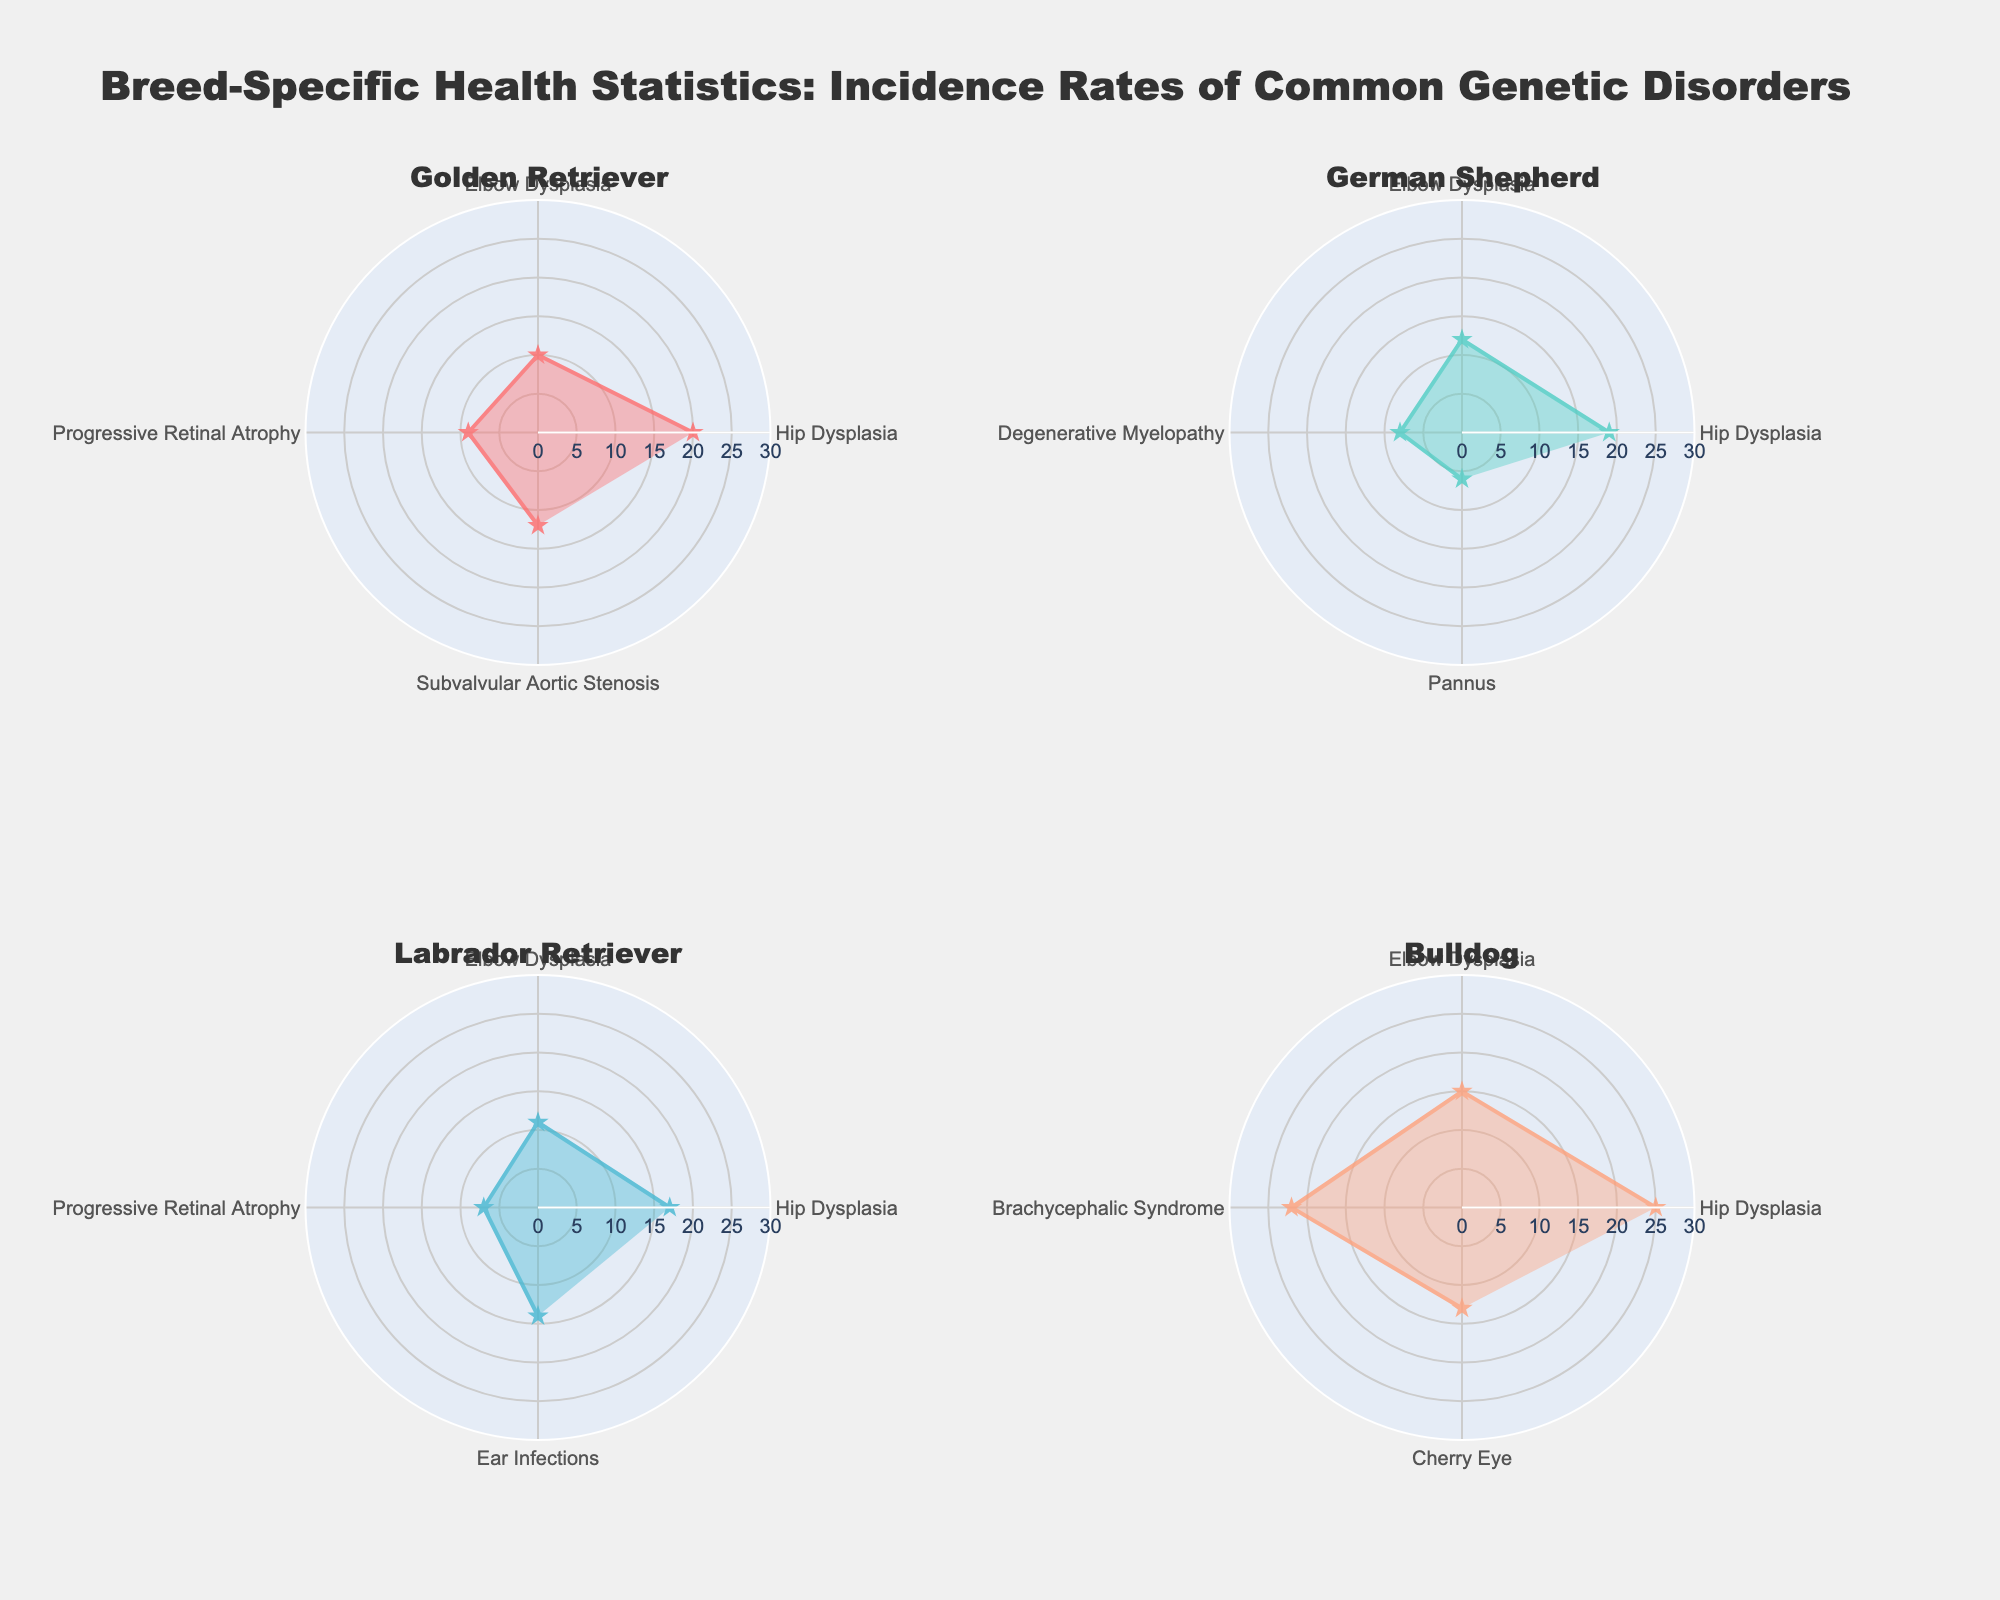What is the title of the figure? The title is usually placed at the top of the figure. In this case, the title is clearly visible in the large text.
Answer: Breed-Specific Health Statistics: Incidence Rates of Common Genetic Disorders Which breed has the highest incidence rate for Hip Dysplasia? To find the breed with the highest incidence for Hip Dysplasia, check the disorder labeled "Hip Dysplasia" and compare the incidence rates for each breed. Confirm the breed with the highest value.
Answer: Bulldog How many disorders are illustrated for the Golden Retriever breed? Look at the subplot specific to Golden Retriever and count the number of unique disorders listed along the radial axis.
Answer: Four Which breed shows the lowest incidence rate for Elbow Dysplasia? Examine the values for Elbow Dysplasia in each breed's subplot and identify the one with the smallest incidence rate.
Answer: Golden Retriever What is the combined incidence rate of Hip Dysplasia and Elbow Dysplasia for German Shepherds? Find and sum the incidence rates for Hip Dysplasia and Elbow Dysplasia specifically within the German Shepherd subplot. Hip Dysplasia is 19 per 1000 and Elbow Dysplasia is 12 per 1000, so add these together.
Answer: 31 Is the incidence rate for Progressive Retinal Atrophy higher in Golden Retrievers than in Labrador Retrievers? Compare the incidence rates of Progressive Retinal Atrophy for both breeds by locating the disorder in their respective subplots.
Answer: Yes Among the disorders listed, which one is unique to Bulldogs? Identify the disorder that appears only in the Bulldog subplot and not in any other breed's.
Answer: Brachycephalic Syndrome What’s the average incidence rate for the disorders shown in the Labrador Retriever subplot? Sum all the incidence rates in the Labrador Retriever subplot and divide by the number of disorders. Disorders are Hip Dysplasia (17), Elbow Dysplasia (11), Progressive Retinal Atrophy (7), and Ear Infections (14), so (17 + 11 + 7 + 14) / 4.
Answer: 12.25 Which breed has the overall lowest incidence rate for all disorders combined? Sum the incidence rates for all disorders for each breed and compare to find the lowest total.
Answer: German Shepherd Does any breed have an incidence rate for any disorder exceeding 20 per 1000? Check each breed’s subplot for disorders with an incidence rate higher than 20 per 1000.
Answer: Yes 